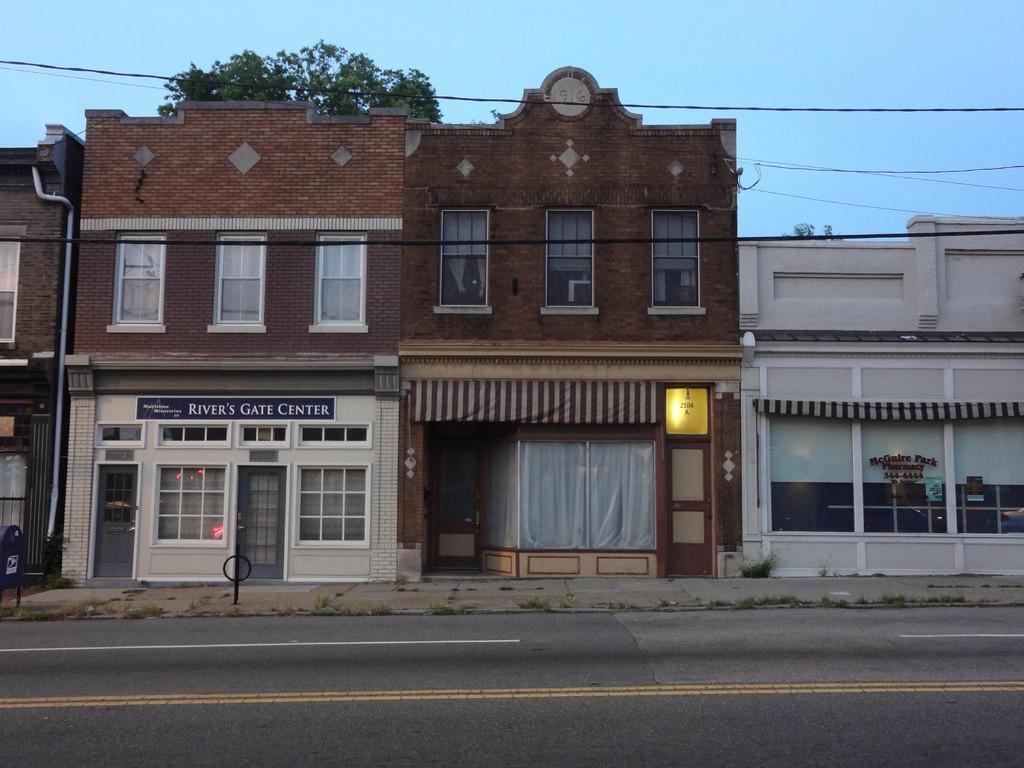Could you give a brief overview of what you see in this image? In this image there is a road at the bottom, Behind the road there are buildings with the windows. At the top there is sky. There are wires above the building. Behind the building there is a tree. 